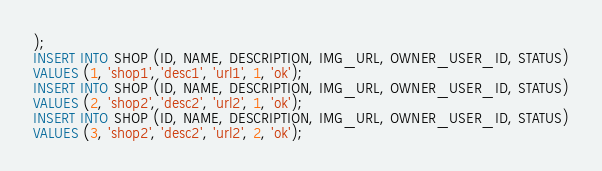<code> <loc_0><loc_0><loc_500><loc_500><_SQL_>);
INSERT INTO SHOP (ID, NAME, DESCRIPTION, IMG_URL, OWNER_USER_ID, STATUS)
VALUES (1, 'shop1', 'desc1', 'url1', 1, 'ok');
INSERT INTO SHOP (ID, NAME, DESCRIPTION, IMG_URL, OWNER_USER_ID, STATUS)
VALUES (2, 'shop2', 'desc2', 'url2', 1, 'ok');
INSERT INTO SHOP (ID, NAME, DESCRIPTION, IMG_URL, OWNER_USER_ID, STATUS)
VALUES (3, 'shop2', 'desc2', 'url2', 2, 'ok');</code> 